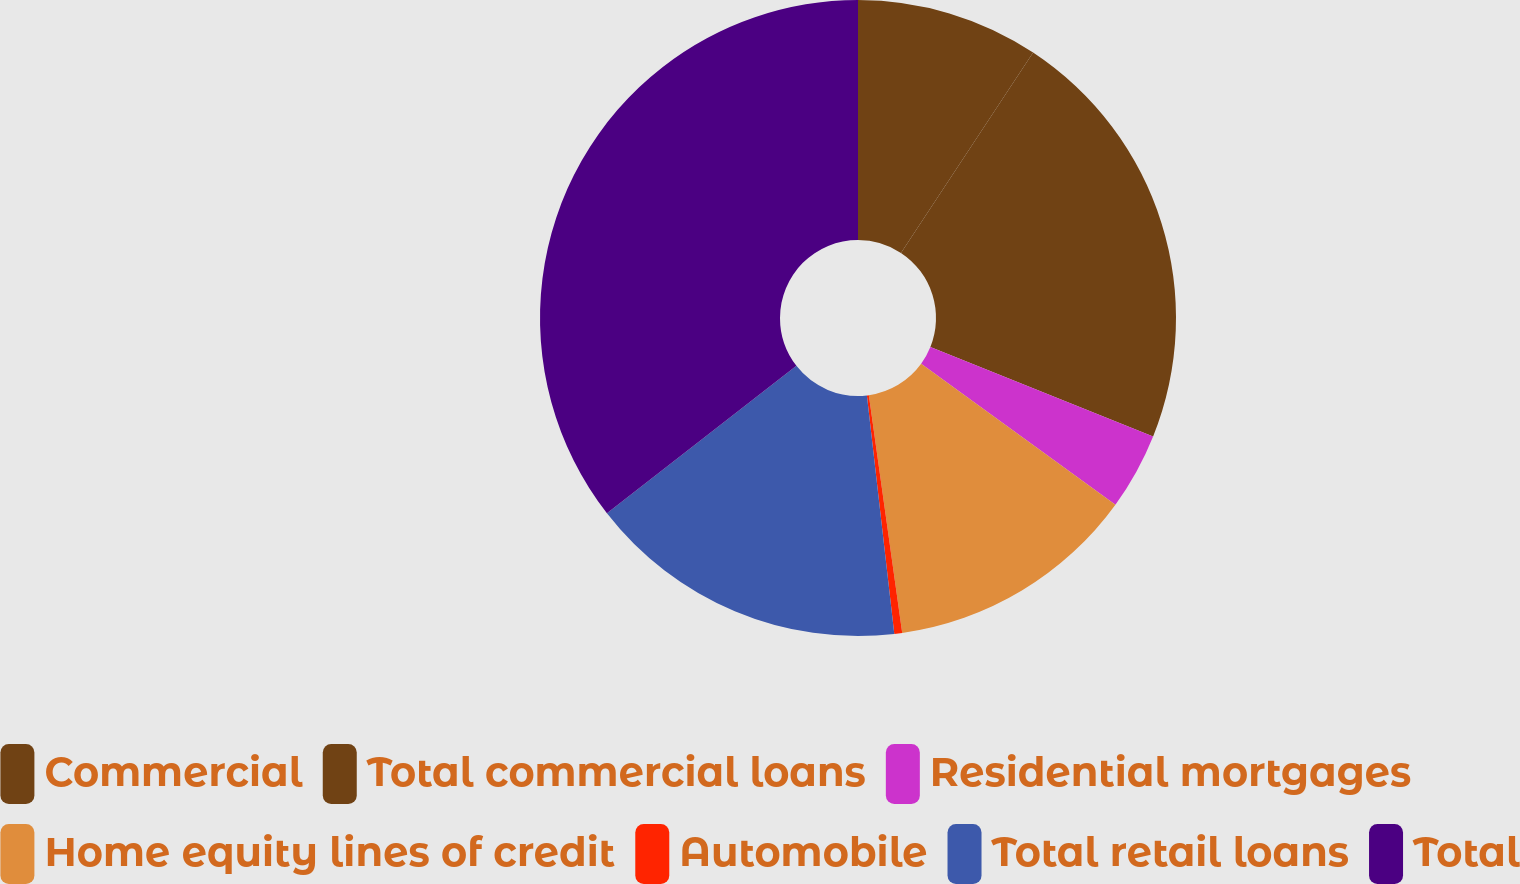Convert chart to OTSL. <chart><loc_0><loc_0><loc_500><loc_500><pie_chart><fcel>Commercial<fcel>Total commercial loans<fcel>Residential mortgages<fcel>Home equity lines of credit<fcel>Automobile<fcel>Total retail loans<fcel>Total<nl><fcel>9.28%<fcel>21.79%<fcel>3.91%<fcel>12.79%<fcel>0.4%<fcel>16.3%<fcel>35.51%<nl></chart> 